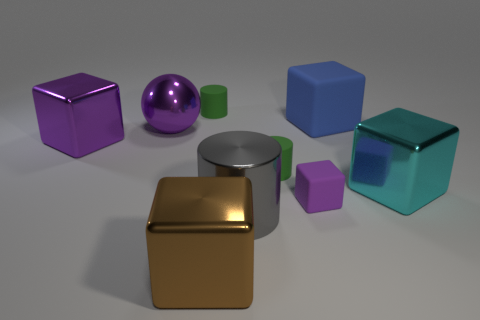There is a large shiny object to the left of the purple metal ball; does it have the same shape as the large cyan metal object?
Provide a succinct answer. Yes. What material is the big purple cube?
Provide a short and direct response. Metal. The tiny green object that is in front of the large ball that is behind the big purple object that is in front of the big purple sphere is what shape?
Your response must be concise. Cylinder. What number of other objects are there of the same shape as the large brown object?
Your response must be concise. 4. Do the tiny rubber cube and the big object left of the metal sphere have the same color?
Keep it short and to the point. Yes. What number of large gray things are there?
Provide a short and direct response. 1. What number of things are either large gray metallic cubes or tiny purple rubber blocks?
Ensure brevity in your answer.  1. There is another block that is the same color as the tiny rubber cube; what is its size?
Ensure brevity in your answer.  Large. Are there any large cyan things to the left of the large brown cube?
Ensure brevity in your answer.  No. Is the number of large cyan things behind the big cyan metal thing greater than the number of tiny green things in front of the gray thing?
Ensure brevity in your answer.  No. 